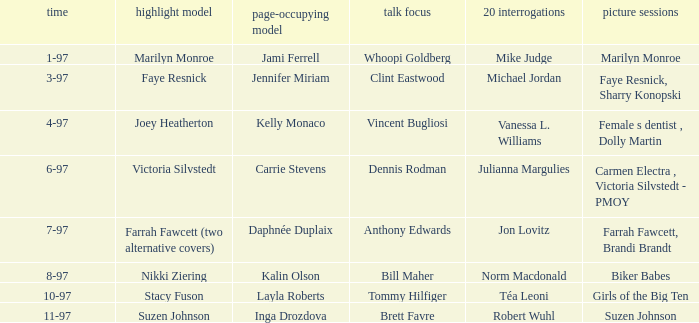When was Kalin Olson listed as  the centerfold model? 8-97. 